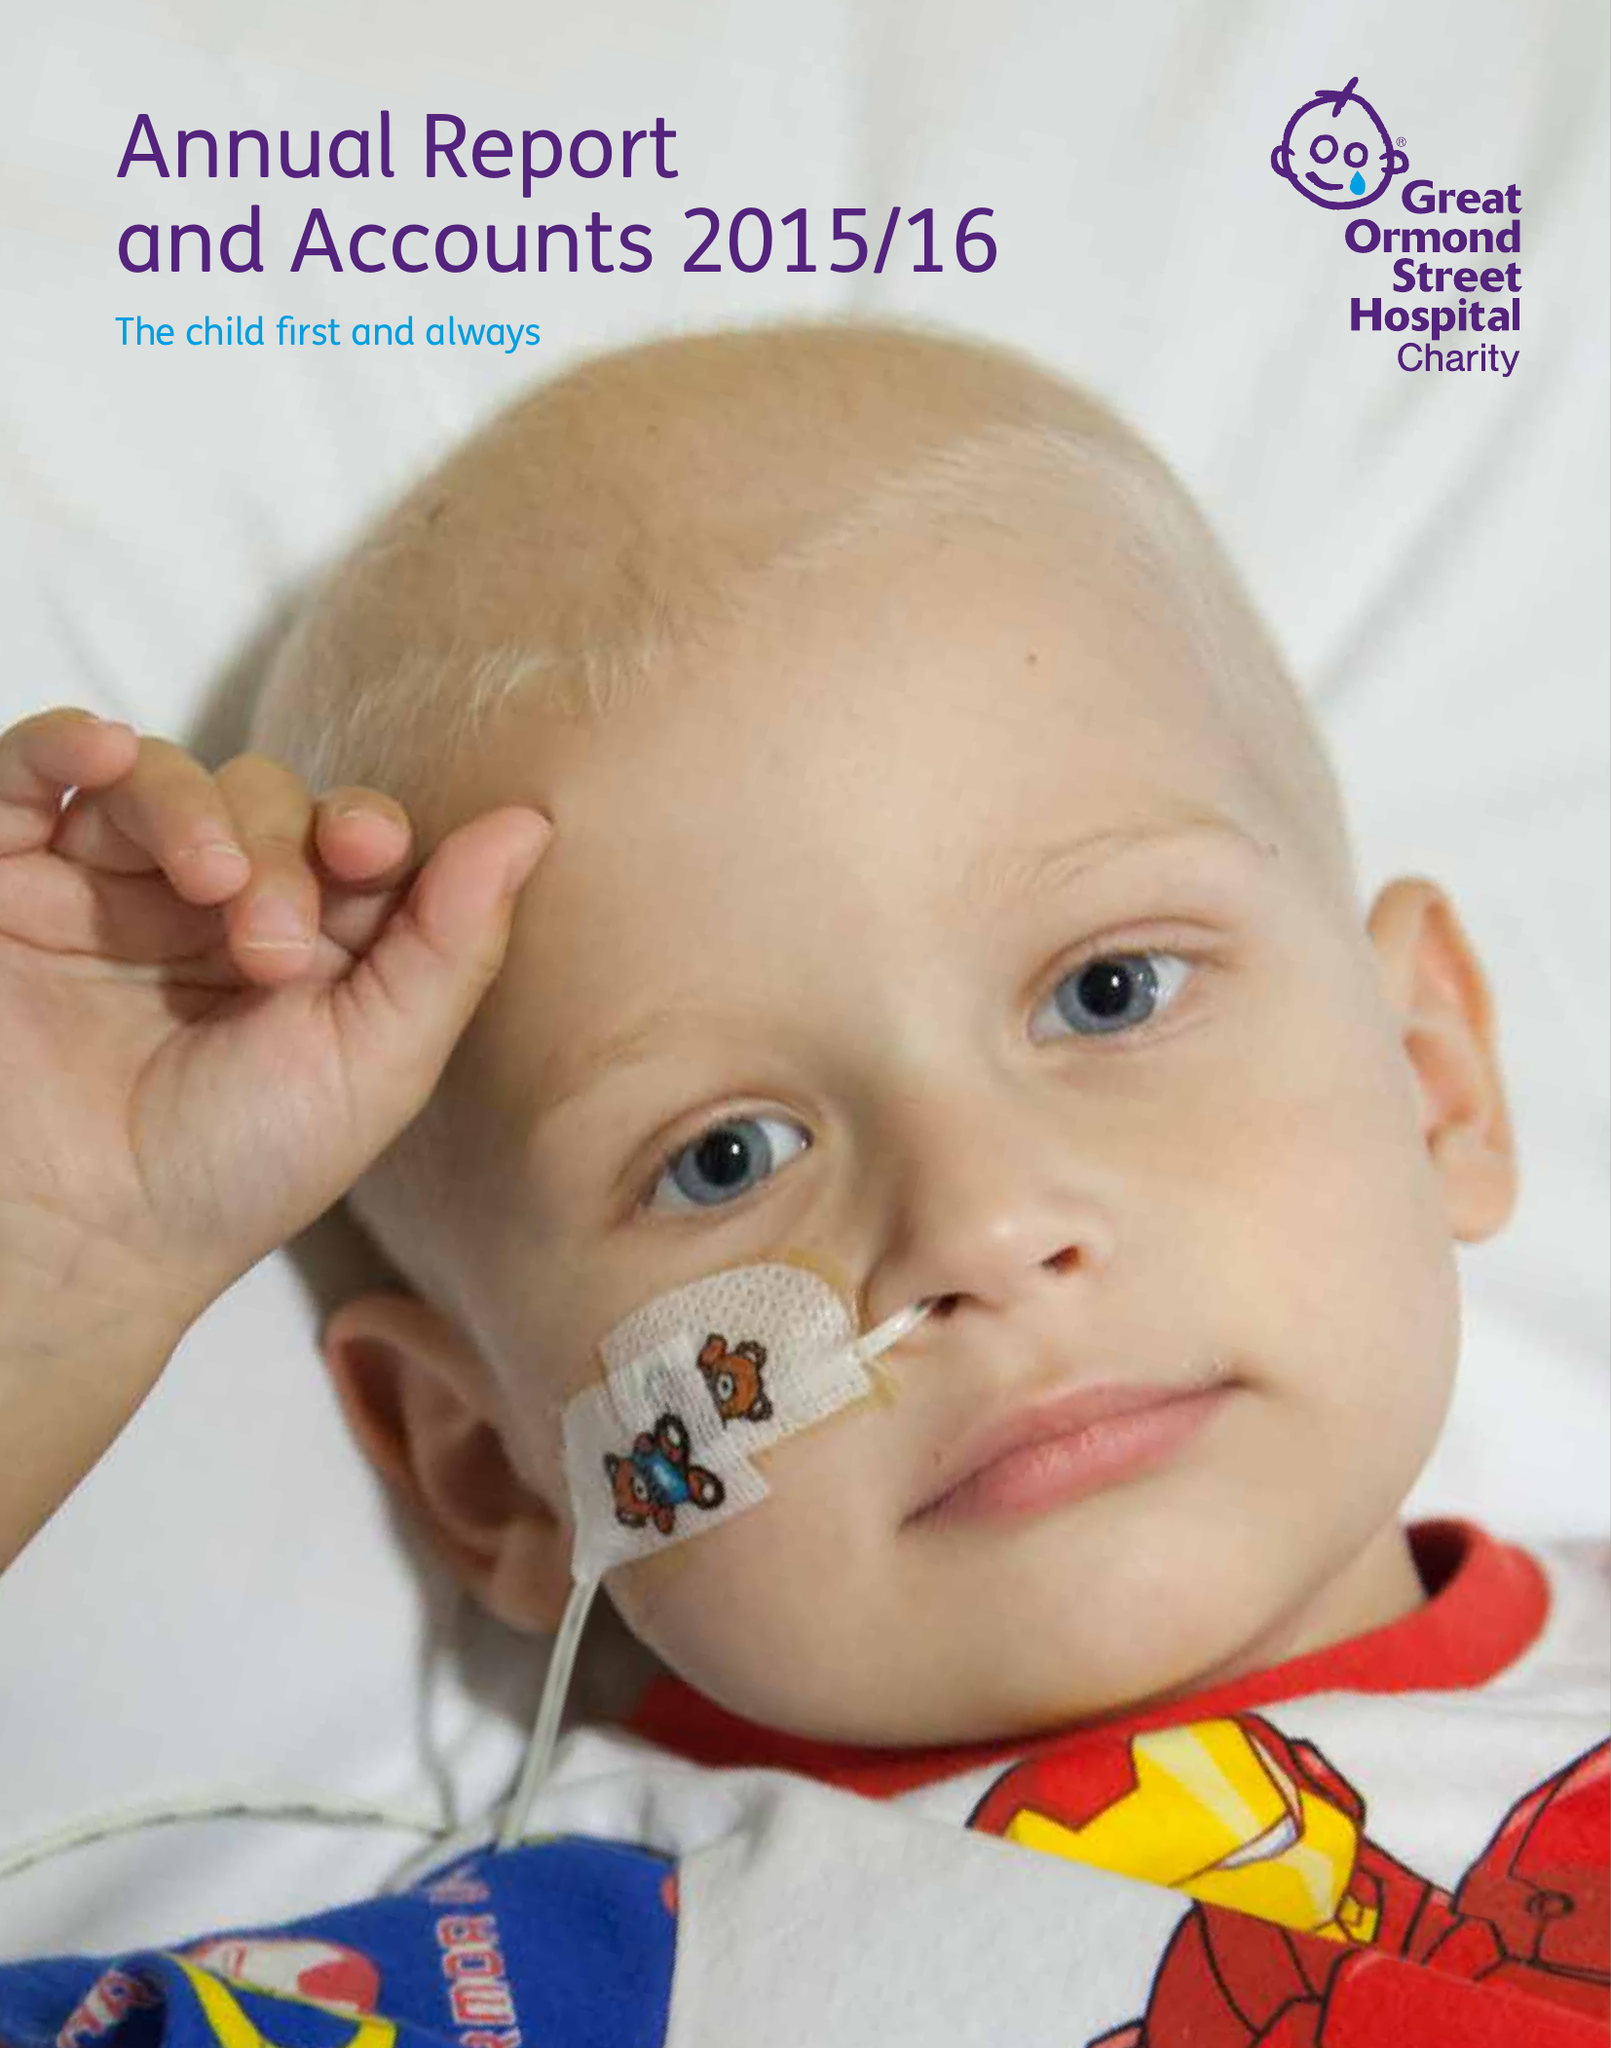What is the value for the address__post_town?
Answer the question using a single word or phrase. LONDON 